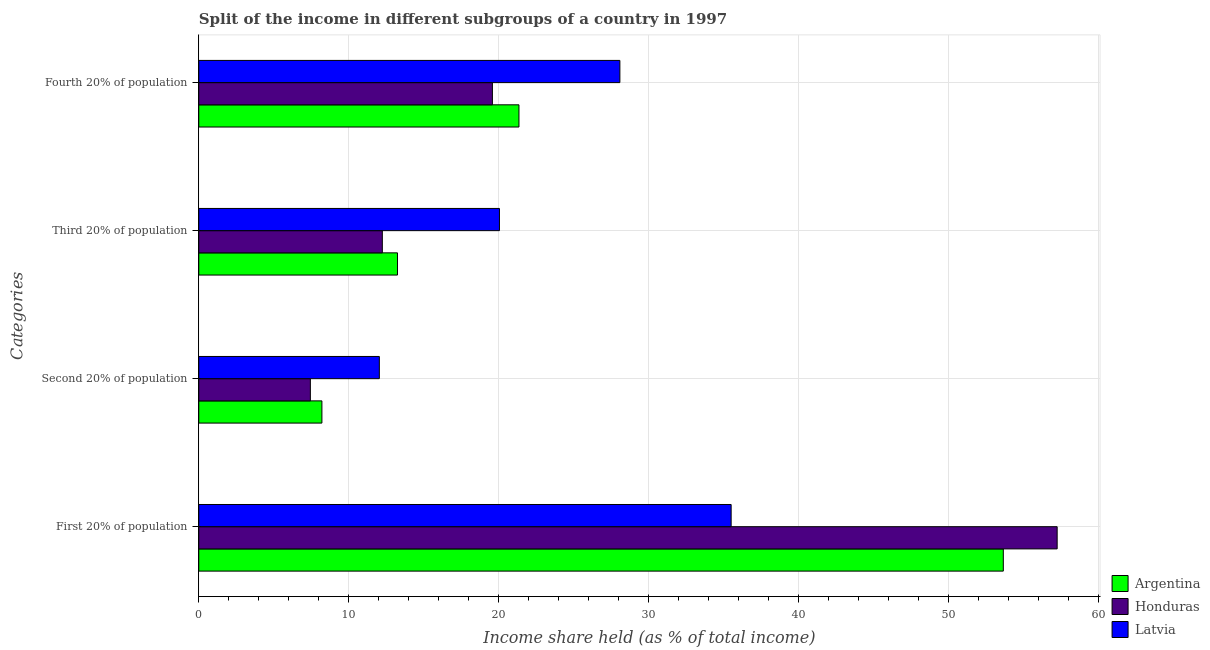How many groups of bars are there?
Make the answer very short. 4. Are the number of bars per tick equal to the number of legend labels?
Your answer should be compact. Yes. How many bars are there on the 3rd tick from the top?
Keep it short and to the point. 3. How many bars are there on the 3rd tick from the bottom?
Provide a short and direct response. 3. What is the label of the 1st group of bars from the top?
Make the answer very short. Fourth 20% of population. What is the share of the income held by fourth 20% of the population in Honduras?
Make the answer very short. 19.58. Across all countries, what is the maximum share of the income held by fourth 20% of the population?
Keep it short and to the point. 28.08. Across all countries, what is the minimum share of the income held by first 20% of the population?
Offer a terse response. 35.5. In which country was the share of the income held by third 20% of the population maximum?
Your answer should be very brief. Latvia. In which country was the share of the income held by third 20% of the population minimum?
Provide a succinct answer. Honduras. What is the total share of the income held by second 20% of the population in the graph?
Ensure brevity in your answer.  27.69. What is the difference between the share of the income held by second 20% of the population in Honduras and that in Argentina?
Keep it short and to the point. -0.77. What is the difference between the share of the income held by third 20% of the population in Argentina and the share of the income held by fourth 20% of the population in Honduras?
Keep it short and to the point. -6.33. What is the average share of the income held by third 20% of the population per country?
Offer a terse response. 15.18. What is the difference between the share of the income held by third 20% of the population and share of the income held by fourth 20% of the population in Latvia?
Give a very brief answer. -8.03. What is the ratio of the share of the income held by fourth 20% of the population in Argentina to that in Latvia?
Your answer should be very brief. 0.76. Is the difference between the share of the income held by second 20% of the population in Honduras and Argentina greater than the difference between the share of the income held by third 20% of the population in Honduras and Argentina?
Your answer should be very brief. Yes. What is the difference between the highest and the second highest share of the income held by third 20% of the population?
Make the answer very short. 6.8. What is the difference between the highest and the lowest share of the income held by first 20% of the population?
Your answer should be very brief. 21.74. Is it the case that in every country, the sum of the share of the income held by second 20% of the population and share of the income held by third 20% of the population is greater than the sum of share of the income held by first 20% of the population and share of the income held by fourth 20% of the population?
Provide a succinct answer. No. What does the 1st bar from the top in Third 20% of population represents?
Offer a terse response. Latvia. What does the 3rd bar from the bottom in Third 20% of population represents?
Your answer should be very brief. Latvia. Are all the bars in the graph horizontal?
Keep it short and to the point. Yes. Does the graph contain grids?
Your answer should be very brief. Yes. How many legend labels are there?
Offer a very short reply. 3. How are the legend labels stacked?
Keep it short and to the point. Vertical. What is the title of the graph?
Your response must be concise. Split of the income in different subgroups of a country in 1997. Does "Mali" appear as one of the legend labels in the graph?
Give a very brief answer. No. What is the label or title of the X-axis?
Ensure brevity in your answer.  Income share held (as % of total income). What is the label or title of the Y-axis?
Your answer should be very brief. Categories. What is the Income share held (as % of total income) of Argentina in First 20% of population?
Your answer should be very brief. 53.65. What is the Income share held (as % of total income) in Honduras in First 20% of population?
Offer a terse response. 57.24. What is the Income share held (as % of total income) in Latvia in First 20% of population?
Your answer should be very brief. 35.5. What is the Income share held (as % of total income) in Argentina in Second 20% of population?
Provide a succinct answer. 8.21. What is the Income share held (as % of total income) of Honduras in Second 20% of population?
Offer a very short reply. 7.44. What is the Income share held (as % of total income) of Latvia in Second 20% of population?
Offer a terse response. 12.04. What is the Income share held (as % of total income) in Argentina in Third 20% of population?
Keep it short and to the point. 13.25. What is the Income share held (as % of total income) in Honduras in Third 20% of population?
Your answer should be compact. 12.24. What is the Income share held (as % of total income) in Latvia in Third 20% of population?
Your response must be concise. 20.05. What is the Income share held (as % of total income) in Argentina in Fourth 20% of population?
Provide a short and direct response. 21.35. What is the Income share held (as % of total income) in Honduras in Fourth 20% of population?
Offer a very short reply. 19.58. What is the Income share held (as % of total income) in Latvia in Fourth 20% of population?
Your answer should be very brief. 28.08. Across all Categories, what is the maximum Income share held (as % of total income) of Argentina?
Ensure brevity in your answer.  53.65. Across all Categories, what is the maximum Income share held (as % of total income) of Honduras?
Give a very brief answer. 57.24. Across all Categories, what is the maximum Income share held (as % of total income) in Latvia?
Ensure brevity in your answer.  35.5. Across all Categories, what is the minimum Income share held (as % of total income) of Argentina?
Your answer should be compact. 8.21. Across all Categories, what is the minimum Income share held (as % of total income) of Honduras?
Offer a very short reply. 7.44. Across all Categories, what is the minimum Income share held (as % of total income) of Latvia?
Make the answer very short. 12.04. What is the total Income share held (as % of total income) of Argentina in the graph?
Make the answer very short. 96.46. What is the total Income share held (as % of total income) in Honduras in the graph?
Offer a terse response. 96.5. What is the total Income share held (as % of total income) in Latvia in the graph?
Make the answer very short. 95.67. What is the difference between the Income share held (as % of total income) in Argentina in First 20% of population and that in Second 20% of population?
Keep it short and to the point. 45.44. What is the difference between the Income share held (as % of total income) of Honduras in First 20% of population and that in Second 20% of population?
Ensure brevity in your answer.  49.8. What is the difference between the Income share held (as % of total income) of Latvia in First 20% of population and that in Second 20% of population?
Offer a terse response. 23.46. What is the difference between the Income share held (as % of total income) of Argentina in First 20% of population and that in Third 20% of population?
Give a very brief answer. 40.4. What is the difference between the Income share held (as % of total income) of Latvia in First 20% of population and that in Third 20% of population?
Offer a very short reply. 15.45. What is the difference between the Income share held (as % of total income) in Argentina in First 20% of population and that in Fourth 20% of population?
Your answer should be very brief. 32.3. What is the difference between the Income share held (as % of total income) in Honduras in First 20% of population and that in Fourth 20% of population?
Keep it short and to the point. 37.66. What is the difference between the Income share held (as % of total income) in Latvia in First 20% of population and that in Fourth 20% of population?
Ensure brevity in your answer.  7.42. What is the difference between the Income share held (as % of total income) in Argentina in Second 20% of population and that in Third 20% of population?
Offer a terse response. -5.04. What is the difference between the Income share held (as % of total income) of Latvia in Second 20% of population and that in Third 20% of population?
Provide a succinct answer. -8.01. What is the difference between the Income share held (as % of total income) of Argentina in Second 20% of population and that in Fourth 20% of population?
Offer a very short reply. -13.14. What is the difference between the Income share held (as % of total income) in Honduras in Second 20% of population and that in Fourth 20% of population?
Keep it short and to the point. -12.14. What is the difference between the Income share held (as % of total income) of Latvia in Second 20% of population and that in Fourth 20% of population?
Offer a terse response. -16.04. What is the difference between the Income share held (as % of total income) of Argentina in Third 20% of population and that in Fourth 20% of population?
Provide a short and direct response. -8.1. What is the difference between the Income share held (as % of total income) in Honduras in Third 20% of population and that in Fourth 20% of population?
Provide a succinct answer. -7.34. What is the difference between the Income share held (as % of total income) of Latvia in Third 20% of population and that in Fourth 20% of population?
Your answer should be compact. -8.03. What is the difference between the Income share held (as % of total income) of Argentina in First 20% of population and the Income share held (as % of total income) of Honduras in Second 20% of population?
Ensure brevity in your answer.  46.21. What is the difference between the Income share held (as % of total income) of Argentina in First 20% of population and the Income share held (as % of total income) of Latvia in Second 20% of population?
Your response must be concise. 41.61. What is the difference between the Income share held (as % of total income) of Honduras in First 20% of population and the Income share held (as % of total income) of Latvia in Second 20% of population?
Your answer should be very brief. 45.2. What is the difference between the Income share held (as % of total income) in Argentina in First 20% of population and the Income share held (as % of total income) in Honduras in Third 20% of population?
Ensure brevity in your answer.  41.41. What is the difference between the Income share held (as % of total income) in Argentina in First 20% of population and the Income share held (as % of total income) in Latvia in Third 20% of population?
Provide a succinct answer. 33.6. What is the difference between the Income share held (as % of total income) of Honduras in First 20% of population and the Income share held (as % of total income) of Latvia in Third 20% of population?
Your answer should be very brief. 37.19. What is the difference between the Income share held (as % of total income) in Argentina in First 20% of population and the Income share held (as % of total income) in Honduras in Fourth 20% of population?
Give a very brief answer. 34.07. What is the difference between the Income share held (as % of total income) of Argentina in First 20% of population and the Income share held (as % of total income) of Latvia in Fourth 20% of population?
Provide a short and direct response. 25.57. What is the difference between the Income share held (as % of total income) of Honduras in First 20% of population and the Income share held (as % of total income) of Latvia in Fourth 20% of population?
Make the answer very short. 29.16. What is the difference between the Income share held (as % of total income) of Argentina in Second 20% of population and the Income share held (as % of total income) of Honduras in Third 20% of population?
Provide a short and direct response. -4.03. What is the difference between the Income share held (as % of total income) in Argentina in Second 20% of population and the Income share held (as % of total income) in Latvia in Third 20% of population?
Offer a very short reply. -11.84. What is the difference between the Income share held (as % of total income) in Honduras in Second 20% of population and the Income share held (as % of total income) in Latvia in Third 20% of population?
Make the answer very short. -12.61. What is the difference between the Income share held (as % of total income) of Argentina in Second 20% of population and the Income share held (as % of total income) of Honduras in Fourth 20% of population?
Keep it short and to the point. -11.37. What is the difference between the Income share held (as % of total income) in Argentina in Second 20% of population and the Income share held (as % of total income) in Latvia in Fourth 20% of population?
Provide a short and direct response. -19.87. What is the difference between the Income share held (as % of total income) in Honduras in Second 20% of population and the Income share held (as % of total income) in Latvia in Fourth 20% of population?
Provide a short and direct response. -20.64. What is the difference between the Income share held (as % of total income) of Argentina in Third 20% of population and the Income share held (as % of total income) of Honduras in Fourth 20% of population?
Your answer should be very brief. -6.33. What is the difference between the Income share held (as % of total income) of Argentina in Third 20% of population and the Income share held (as % of total income) of Latvia in Fourth 20% of population?
Give a very brief answer. -14.83. What is the difference between the Income share held (as % of total income) in Honduras in Third 20% of population and the Income share held (as % of total income) in Latvia in Fourth 20% of population?
Your answer should be very brief. -15.84. What is the average Income share held (as % of total income) in Argentina per Categories?
Give a very brief answer. 24.11. What is the average Income share held (as % of total income) of Honduras per Categories?
Your response must be concise. 24.12. What is the average Income share held (as % of total income) of Latvia per Categories?
Give a very brief answer. 23.92. What is the difference between the Income share held (as % of total income) in Argentina and Income share held (as % of total income) in Honduras in First 20% of population?
Your response must be concise. -3.59. What is the difference between the Income share held (as % of total income) in Argentina and Income share held (as % of total income) in Latvia in First 20% of population?
Keep it short and to the point. 18.15. What is the difference between the Income share held (as % of total income) in Honduras and Income share held (as % of total income) in Latvia in First 20% of population?
Offer a very short reply. 21.74. What is the difference between the Income share held (as % of total income) in Argentina and Income share held (as % of total income) in Honduras in Second 20% of population?
Give a very brief answer. 0.77. What is the difference between the Income share held (as % of total income) in Argentina and Income share held (as % of total income) in Latvia in Second 20% of population?
Provide a succinct answer. -3.83. What is the difference between the Income share held (as % of total income) of Argentina and Income share held (as % of total income) of Latvia in Third 20% of population?
Provide a short and direct response. -6.8. What is the difference between the Income share held (as % of total income) of Honduras and Income share held (as % of total income) of Latvia in Third 20% of population?
Give a very brief answer. -7.81. What is the difference between the Income share held (as % of total income) of Argentina and Income share held (as % of total income) of Honduras in Fourth 20% of population?
Your answer should be compact. 1.77. What is the difference between the Income share held (as % of total income) of Argentina and Income share held (as % of total income) of Latvia in Fourth 20% of population?
Ensure brevity in your answer.  -6.73. What is the difference between the Income share held (as % of total income) of Honduras and Income share held (as % of total income) of Latvia in Fourth 20% of population?
Make the answer very short. -8.5. What is the ratio of the Income share held (as % of total income) in Argentina in First 20% of population to that in Second 20% of population?
Give a very brief answer. 6.53. What is the ratio of the Income share held (as % of total income) in Honduras in First 20% of population to that in Second 20% of population?
Keep it short and to the point. 7.69. What is the ratio of the Income share held (as % of total income) in Latvia in First 20% of population to that in Second 20% of population?
Provide a short and direct response. 2.95. What is the ratio of the Income share held (as % of total income) in Argentina in First 20% of population to that in Third 20% of population?
Your response must be concise. 4.05. What is the ratio of the Income share held (as % of total income) of Honduras in First 20% of population to that in Third 20% of population?
Your response must be concise. 4.68. What is the ratio of the Income share held (as % of total income) in Latvia in First 20% of population to that in Third 20% of population?
Provide a succinct answer. 1.77. What is the ratio of the Income share held (as % of total income) in Argentina in First 20% of population to that in Fourth 20% of population?
Give a very brief answer. 2.51. What is the ratio of the Income share held (as % of total income) of Honduras in First 20% of population to that in Fourth 20% of population?
Provide a succinct answer. 2.92. What is the ratio of the Income share held (as % of total income) of Latvia in First 20% of population to that in Fourth 20% of population?
Offer a very short reply. 1.26. What is the ratio of the Income share held (as % of total income) of Argentina in Second 20% of population to that in Third 20% of population?
Offer a terse response. 0.62. What is the ratio of the Income share held (as % of total income) of Honduras in Second 20% of population to that in Third 20% of population?
Provide a succinct answer. 0.61. What is the ratio of the Income share held (as % of total income) in Latvia in Second 20% of population to that in Third 20% of population?
Provide a short and direct response. 0.6. What is the ratio of the Income share held (as % of total income) in Argentina in Second 20% of population to that in Fourth 20% of population?
Your response must be concise. 0.38. What is the ratio of the Income share held (as % of total income) in Honduras in Second 20% of population to that in Fourth 20% of population?
Your response must be concise. 0.38. What is the ratio of the Income share held (as % of total income) of Latvia in Second 20% of population to that in Fourth 20% of population?
Provide a succinct answer. 0.43. What is the ratio of the Income share held (as % of total income) of Argentina in Third 20% of population to that in Fourth 20% of population?
Your answer should be compact. 0.62. What is the ratio of the Income share held (as % of total income) of Honduras in Third 20% of population to that in Fourth 20% of population?
Your response must be concise. 0.63. What is the ratio of the Income share held (as % of total income) in Latvia in Third 20% of population to that in Fourth 20% of population?
Provide a succinct answer. 0.71. What is the difference between the highest and the second highest Income share held (as % of total income) in Argentina?
Keep it short and to the point. 32.3. What is the difference between the highest and the second highest Income share held (as % of total income) in Honduras?
Your answer should be compact. 37.66. What is the difference between the highest and the second highest Income share held (as % of total income) of Latvia?
Offer a very short reply. 7.42. What is the difference between the highest and the lowest Income share held (as % of total income) of Argentina?
Provide a short and direct response. 45.44. What is the difference between the highest and the lowest Income share held (as % of total income) of Honduras?
Make the answer very short. 49.8. What is the difference between the highest and the lowest Income share held (as % of total income) in Latvia?
Your answer should be compact. 23.46. 